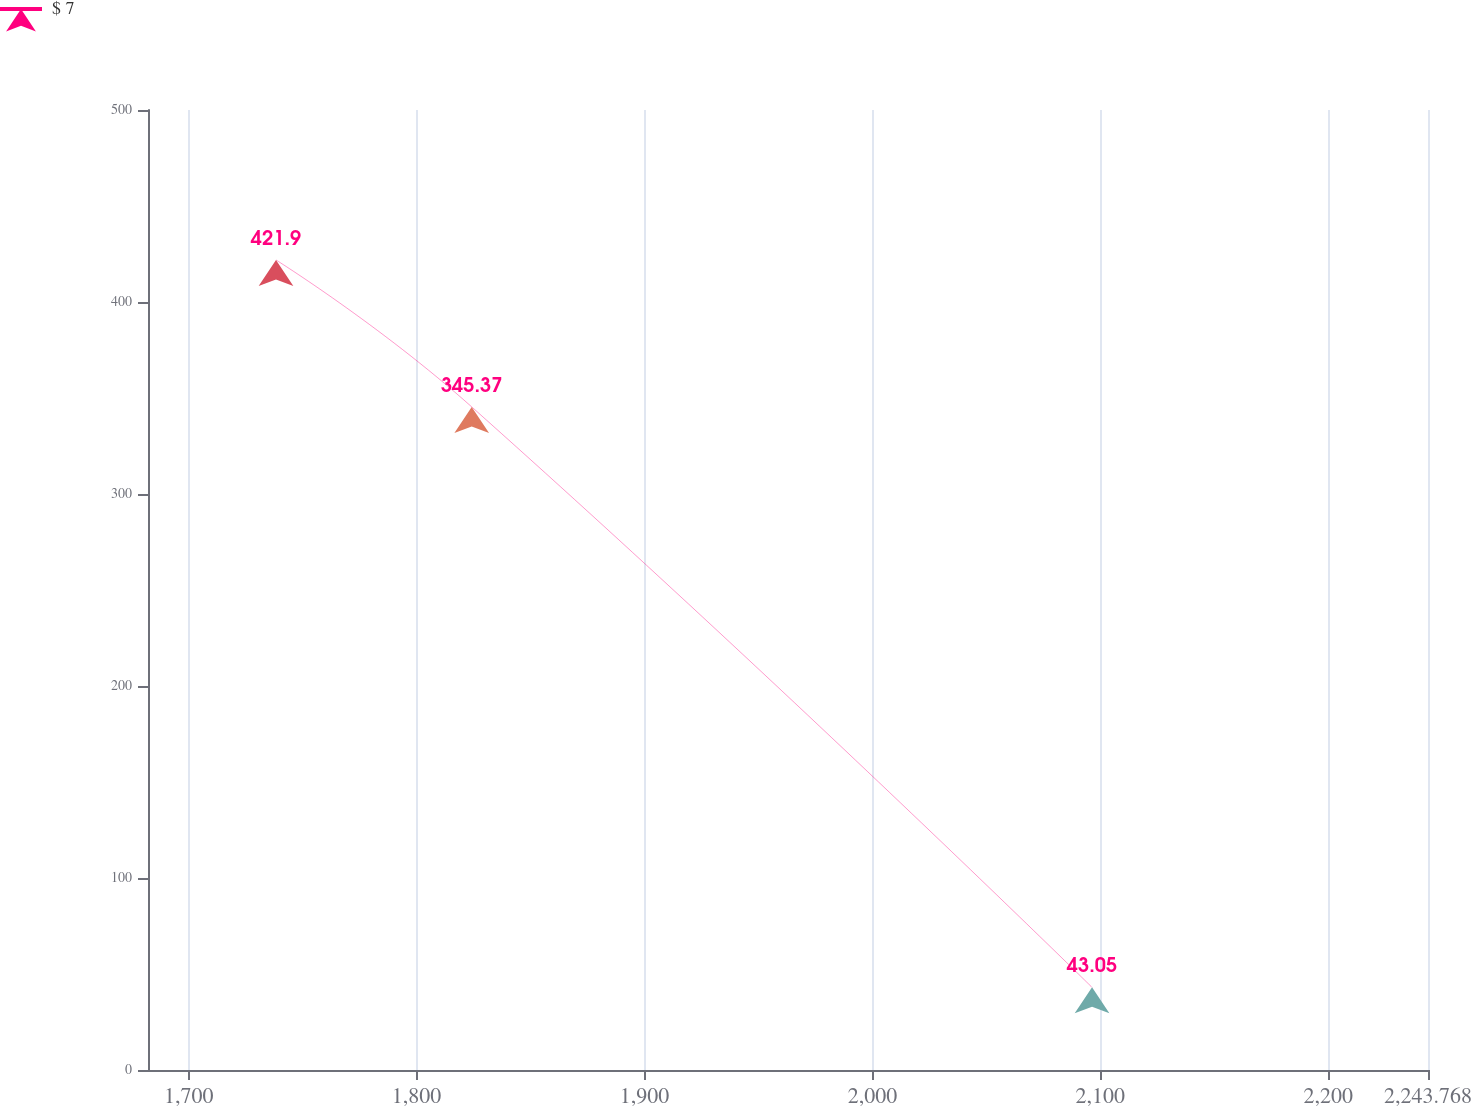Convert chart. <chart><loc_0><loc_0><loc_500><loc_500><line_chart><ecel><fcel>$ 7<nl><fcel>1738.31<fcel>421.9<nl><fcel>1824.18<fcel>345.37<nl><fcel>2096.36<fcel>43.05<nl><fcel>2299.93<fcel>0.96<nl></chart> 